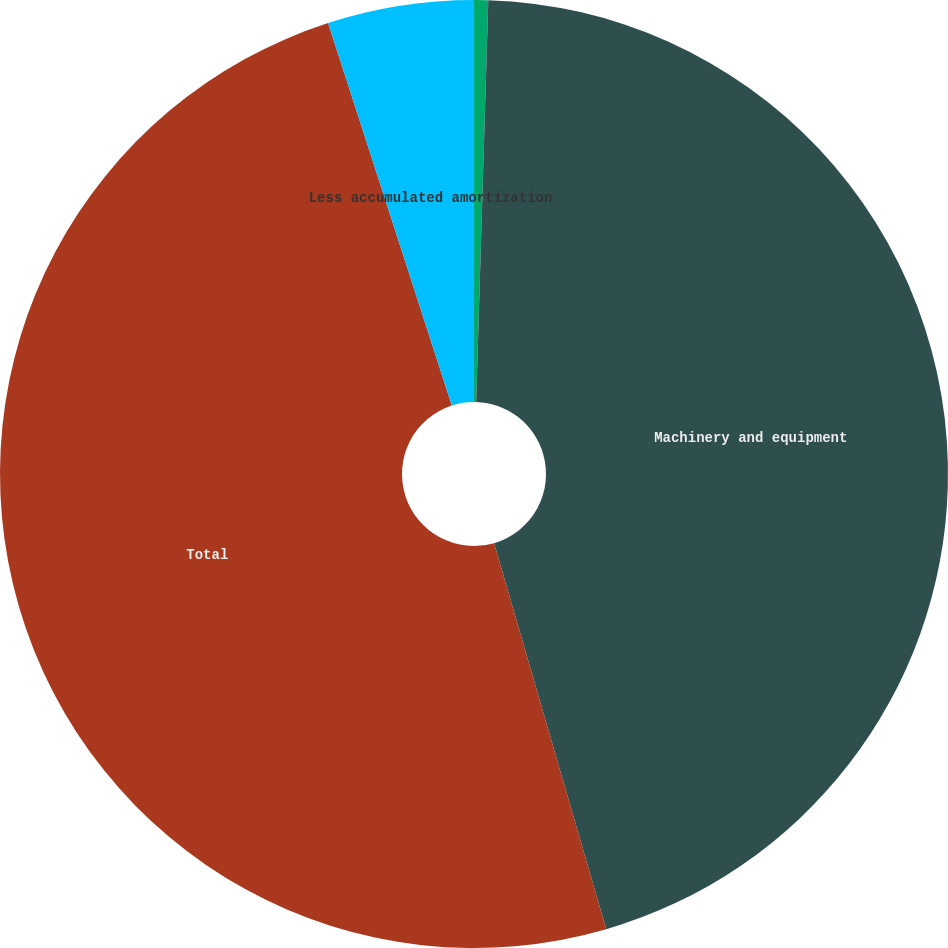<chart> <loc_0><loc_0><loc_500><loc_500><pie_chart><fcel>Buildings<fcel>Machinery and equipment<fcel>Total<fcel>Less accumulated amortization<nl><fcel>0.48%<fcel>45.02%<fcel>49.52%<fcel>4.98%<nl></chart> 